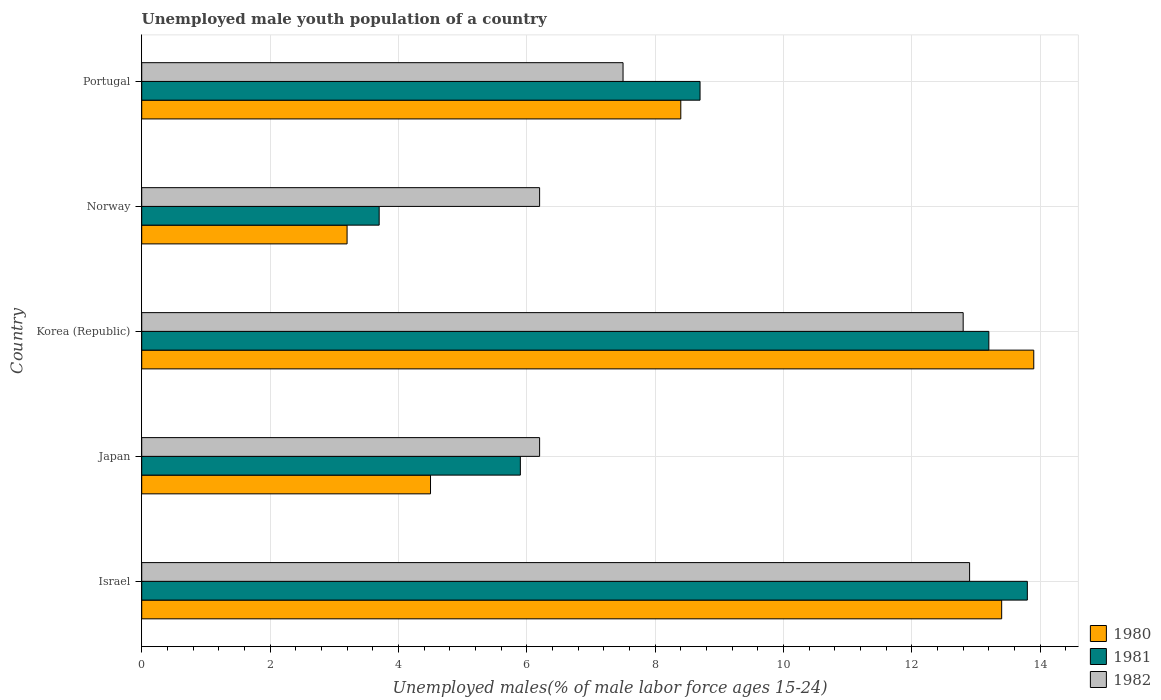How many different coloured bars are there?
Give a very brief answer. 3. Are the number of bars per tick equal to the number of legend labels?
Your answer should be compact. Yes. Are the number of bars on each tick of the Y-axis equal?
Offer a terse response. Yes. What is the label of the 2nd group of bars from the top?
Offer a very short reply. Norway. In how many cases, is the number of bars for a given country not equal to the number of legend labels?
Offer a terse response. 0. What is the percentage of unemployed male youth population in 1981 in Israel?
Your answer should be very brief. 13.8. Across all countries, what is the maximum percentage of unemployed male youth population in 1982?
Provide a succinct answer. 12.9. Across all countries, what is the minimum percentage of unemployed male youth population in 1980?
Keep it short and to the point. 3.2. In which country was the percentage of unemployed male youth population in 1980 maximum?
Offer a very short reply. Korea (Republic). In which country was the percentage of unemployed male youth population in 1981 minimum?
Your response must be concise. Norway. What is the total percentage of unemployed male youth population in 1981 in the graph?
Provide a short and direct response. 45.3. What is the difference between the percentage of unemployed male youth population in 1980 in Japan and that in Portugal?
Make the answer very short. -3.9. What is the difference between the percentage of unemployed male youth population in 1980 in Japan and the percentage of unemployed male youth population in 1981 in Korea (Republic)?
Provide a short and direct response. -8.7. What is the average percentage of unemployed male youth population in 1980 per country?
Give a very brief answer. 8.68. What is the ratio of the percentage of unemployed male youth population in 1982 in Norway to that in Portugal?
Offer a very short reply. 0.83. Is the difference between the percentage of unemployed male youth population in 1980 in Israel and Japan greater than the difference between the percentage of unemployed male youth population in 1981 in Israel and Japan?
Your answer should be compact. Yes. What is the difference between the highest and the second highest percentage of unemployed male youth population in 1980?
Provide a succinct answer. 0.5. What is the difference between the highest and the lowest percentage of unemployed male youth population in 1981?
Keep it short and to the point. 10.1. Is the sum of the percentage of unemployed male youth population in 1980 in Israel and Korea (Republic) greater than the maximum percentage of unemployed male youth population in 1981 across all countries?
Keep it short and to the point. Yes. What does the 3rd bar from the top in Israel represents?
Offer a very short reply. 1980. Is it the case that in every country, the sum of the percentage of unemployed male youth population in 1982 and percentage of unemployed male youth population in 1980 is greater than the percentage of unemployed male youth population in 1981?
Provide a short and direct response. Yes. Are all the bars in the graph horizontal?
Provide a short and direct response. Yes. What is the difference between two consecutive major ticks on the X-axis?
Ensure brevity in your answer.  2. Does the graph contain grids?
Give a very brief answer. Yes. Where does the legend appear in the graph?
Provide a succinct answer. Bottom right. How are the legend labels stacked?
Provide a short and direct response. Vertical. What is the title of the graph?
Make the answer very short. Unemployed male youth population of a country. Does "1988" appear as one of the legend labels in the graph?
Your response must be concise. No. What is the label or title of the X-axis?
Your response must be concise. Unemployed males(% of male labor force ages 15-24). What is the Unemployed males(% of male labor force ages 15-24) in 1980 in Israel?
Provide a short and direct response. 13.4. What is the Unemployed males(% of male labor force ages 15-24) in 1981 in Israel?
Your response must be concise. 13.8. What is the Unemployed males(% of male labor force ages 15-24) of 1982 in Israel?
Provide a succinct answer. 12.9. What is the Unemployed males(% of male labor force ages 15-24) of 1981 in Japan?
Offer a very short reply. 5.9. What is the Unemployed males(% of male labor force ages 15-24) of 1982 in Japan?
Make the answer very short. 6.2. What is the Unemployed males(% of male labor force ages 15-24) in 1980 in Korea (Republic)?
Your answer should be compact. 13.9. What is the Unemployed males(% of male labor force ages 15-24) in 1981 in Korea (Republic)?
Ensure brevity in your answer.  13.2. What is the Unemployed males(% of male labor force ages 15-24) in 1982 in Korea (Republic)?
Your answer should be compact. 12.8. What is the Unemployed males(% of male labor force ages 15-24) of 1980 in Norway?
Ensure brevity in your answer.  3.2. What is the Unemployed males(% of male labor force ages 15-24) in 1981 in Norway?
Offer a very short reply. 3.7. What is the Unemployed males(% of male labor force ages 15-24) of 1982 in Norway?
Your response must be concise. 6.2. What is the Unemployed males(% of male labor force ages 15-24) in 1980 in Portugal?
Keep it short and to the point. 8.4. What is the Unemployed males(% of male labor force ages 15-24) of 1981 in Portugal?
Provide a short and direct response. 8.7. Across all countries, what is the maximum Unemployed males(% of male labor force ages 15-24) of 1980?
Make the answer very short. 13.9. Across all countries, what is the maximum Unemployed males(% of male labor force ages 15-24) in 1981?
Make the answer very short. 13.8. Across all countries, what is the maximum Unemployed males(% of male labor force ages 15-24) of 1982?
Offer a very short reply. 12.9. Across all countries, what is the minimum Unemployed males(% of male labor force ages 15-24) of 1980?
Offer a very short reply. 3.2. Across all countries, what is the minimum Unemployed males(% of male labor force ages 15-24) in 1981?
Provide a succinct answer. 3.7. Across all countries, what is the minimum Unemployed males(% of male labor force ages 15-24) in 1982?
Your answer should be very brief. 6.2. What is the total Unemployed males(% of male labor force ages 15-24) of 1980 in the graph?
Make the answer very short. 43.4. What is the total Unemployed males(% of male labor force ages 15-24) of 1981 in the graph?
Your answer should be compact. 45.3. What is the total Unemployed males(% of male labor force ages 15-24) of 1982 in the graph?
Provide a succinct answer. 45.6. What is the difference between the Unemployed males(% of male labor force ages 15-24) in 1980 in Israel and that in Japan?
Keep it short and to the point. 8.9. What is the difference between the Unemployed males(% of male labor force ages 15-24) of 1981 in Israel and that in Japan?
Make the answer very short. 7.9. What is the difference between the Unemployed males(% of male labor force ages 15-24) in 1981 in Israel and that in Korea (Republic)?
Keep it short and to the point. 0.6. What is the difference between the Unemployed males(% of male labor force ages 15-24) of 1980 in Israel and that in Norway?
Offer a very short reply. 10.2. What is the difference between the Unemployed males(% of male labor force ages 15-24) of 1981 in Israel and that in Norway?
Offer a very short reply. 10.1. What is the difference between the Unemployed males(% of male labor force ages 15-24) in 1980 in Israel and that in Portugal?
Provide a short and direct response. 5. What is the difference between the Unemployed males(% of male labor force ages 15-24) in 1982 in Israel and that in Portugal?
Offer a terse response. 5.4. What is the difference between the Unemployed males(% of male labor force ages 15-24) in 1980 in Japan and that in Korea (Republic)?
Your response must be concise. -9.4. What is the difference between the Unemployed males(% of male labor force ages 15-24) of 1981 in Japan and that in Korea (Republic)?
Keep it short and to the point. -7.3. What is the difference between the Unemployed males(% of male labor force ages 15-24) in 1982 in Japan and that in Korea (Republic)?
Make the answer very short. -6.6. What is the difference between the Unemployed males(% of male labor force ages 15-24) of 1980 in Japan and that in Norway?
Provide a succinct answer. 1.3. What is the difference between the Unemployed males(% of male labor force ages 15-24) in 1980 in Japan and that in Portugal?
Provide a short and direct response. -3.9. What is the difference between the Unemployed males(% of male labor force ages 15-24) in 1981 in Japan and that in Portugal?
Your answer should be compact. -2.8. What is the difference between the Unemployed males(% of male labor force ages 15-24) of 1980 in Korea (Republic) and that in Norway?
Make the answer very short. 10.7. What is the difference between the Unemployed males(% of male labor force ages 15-24) in 1981 in Korea (Republic) and that in Norway?
Provide a succinct answer. 9.5. What is the difference between the Unemployed males(% of male labor force ages 15-24) in 1980 in Korea (Republic) and that in Portugal?
Give a very brief answer. 5.5. What is the difference between the Unemployed males(% of male labor force ages 15-24) in 1982 in Norway and that in Portugal?
Give a very brief answer. -1.3. What is the difference between the Unemployed males(% of male labor force ages 15-24) in 1981 in Israel and the Unemployed males(% of male labor force ages 15-24) in 1982 in Japan?
Offer a terse response. 7.6. What is the difference between the Unemployed males(% of male labor force ages 15-24) in 1980 in Israel and the Unemployed males(% of male labor force ages 15-24) in 1981 in Korea (Republic)?
Provide a succinct answer. 0.2. What is the difference between the Unemployed males(% of male labor force ages 15-24) of 1981 in Israel and the Unemployed males(% of male labor force ages 15-24) of 1982 in Korea (Republic)?
Offer a terse response. 1. What is the difference between the Unemployed males(% of male labor force ages 15-24) of 1980 in Israel and the Unemployed males(% of male labor force ages 15-24) of 1982 in Norway?
Give a very brief answer. 7.2. What is the difference between the Unemployed males(% of male labor force ages 15-24) in 1980 in Israel and the Unemployed males(% of male labor force ages 15-24) in 1981 in Portugal?
Offer a very short reply. 4.7. What is the difference between the Unemployed males(% of male labor force ages 15-24) in 1980 in Japan and the Unemployed males(% of male labor force ages 15-24) in 1981 in Norway?
Give a very brief answer. 0.8. What is the difference between the Unemployed males(% of male labor force ages 15-24) in 1981 in Japan and the Unemployed males(% of male labor force ages 15-24) in 1982 in Norway?
Provide a succinct answer. -0.3. What is the difference between the Unemployed males(% of male labor force ages 15-24) in 1981 in Japan and the Unemployed males(% of male labor force ages 15-24) in 1982 in Portugal?
Provide a succinct answer. -1.6. What is the difference between the Unemployed males(% of male labor force ages 15-24) of 1980 in Korea (Republic) and the Unemployed males(% of male labor force ages 15-24) of 1982 in Norway?
Offer a very short reply. 7.7. What is the difference between the Unemployed males(% of male labor force ages 15-24) of 1981 in Korea (Republic) and the Unemployed males(% of male labor force ages 15-24) of 1982 in Norway?
Make the answer very short. 7. What is the difference between the Unemployed males(% of male labor force ages 15-24) of 1980 in Korea (Republic) and the Unemployed males(% of male labor force ages 15-24) of 1982 in Portugal?
Your response must be concise. 6.4. What is the difference between the Unemployed males(% of male labor force ages 15-24) in 1980 in Norway and the Unemployed males(% of male labor force ages 15-24) in 1981 in Portugal?
Your answer should be compact. -5.5. What is the difference between the Unemployed males(% of male labor force ages 15-24) of 1980 in Norway and the Unemployed males(% of male labor force ages 15-24) of 1982 in Portugal?
Offer a terse response. -4.3. What is the difference between the Unemployed males(% of male labor force ages 15-24) of 1981 in Norway and the Unemployed males(% of male labor force ages 15-24) of 1982 in Portugal?
Give a very brief answer. -3.8. What is the average Unemployed males(% of male labor force ages 15-24) in 1980 per country?
Offer a terse response. 8.68. What is the average Unemployed males(% of male labor force ages 15-24) in 1981 per country?
Give a very brief answer. 9.06. What is the average Unemployed males(% of male labor force ages 15-24) of 1982 per country?
Provide a succinct answer. 9.12. What is the difference between the Unemployed males(% of male labor force ages 15-24) of 1980 and Unemployed males(% of male labor force ages 15-24) of 1981 in Israel?
Offer a very short reply. -0.4. What is the difference between the Unemployed males(% of male labor force ages 15-24) in 1980 and Unemployed males(% of male labor force ages 15-24) in 1982 in Israel?
Ensure brevity in your answer.  0.5. What is the difference between the Unemployed males(% of male labor force ages 15-24) of 1980 and Unemployed males(% of male labor force ages 15-24) of 1981 in Japan?
Make the answer very short. -1.4. What is the difference between the Unemployed males(% of male labor force ages 15-24) of 1981 and Unemployed males(% of male labor force ages 15-24) of 1982 in Japan?
Offer a very short reply. -0.3. What is the difference between the Unemployed males(% of male labor force ages 15-24) in 1980 and Unemployed males(% of male labor force ages 15-24) in 1982 in Norway?
Offer a very short reply. -3. What is the difference between the Unemployed males(% of male labor force ages 15-24) of 1980 and Unemployed males(% of male labor force ages 15-24) of 1981 in Portugal?
Provide a succinct answer. -0.3. What is the difference between the Unemployed males(% of male labor force ages 15-24) in 1980 and Unemployed males(% of male labor force ages 15-24) in 1982 in Portugal?
Keep it short and to the point. 0.9. What is the ratio of the Unemployed males(% of male labor force ages 15-24) of 1980 in Israel to that in Japan?
Keep it short and to the point. 2.98. What is the ratio of the Unemployed males(% of male labor force ages 15-24) of 1981 in Israel to that in Japan?
Keep it short and to the point. 2.34. What is the ratio of the Unemployed males(% of male labor force ages 15-24) in 1982 in Israel to that in Japan?
Ensure brevity in your answer.  2.08. What is the ratio of the Unemployed males(% of male labor force ages 15-24) in 1980 in Israel to that in Korea (Republic)?
Ensure brevity in your answer.  0.96. What is the ratio of the Unemployed males(% of male labor force ages 15-24) of 1981 in Israel to that in Korea (Republic)?
Provide a succinct answer. 1.05. What is the ratio of the Unemployed males(% of male labor force ages 15-24) of 1980 in Israel to that in Norway?
Provide a succinct answer. 4.19. What is the ratio of the Unemployed males(% of male labor force ages 15-24) of 1981 in Israel to that in Norway?
Ensure brevity in your answer.  3.73. What is the ratio of the Unemployed males(% of male labor force ages 15-24) of 1982 in Israel to that in Norway?
Ensure brevity in your answer.  2.08. What is the ratio of the Unemployed males(% of male labor force ages 15-24) of 1980 in Israel to that in Portugal?
Your response must be concise. 1.6. What is the ratio of the Unemployed males(% of male labor force ages 15-24) of 1981 in Israel to that in Portugal?
Provide a short and direct response. 1.59. What is the ratio of the Unemployed males(% of male labor force ages 15-24) in 1982 in Israel to that in Portugal?
Offer a terse response. 1.72. What is the ratio of the Unemployed males(% of male labor force ages 15-24) in 1980 in Japan to that in Korea (Republic)?
Provide a succinct answer. 0.32. What is the ratio of the Unemployed males(% of male labor force ages 15-24) of 1981 in Japan to that in Korea (Republic)?
Provide a succinct answer. 0.45. What is the ratio of the Unemployed males(% of male labor force ages 15-24) in 1982 in Japan to that in Korea (Republic)?
Your answer should be compact. 0.48. What is the ratio of the Unemployed males(% of male labor force ages 15-24) of 1980 in Japan to that in Norway?
Your answer should be compact. 1.41. What is the ratio of the Unemployed males(% of male labor force ages 15-24) of 1981 in Japan to that in Norway?
Provide a short and direct response. 1.59. What is the ratio of the Unemployed males(% of male labor force ages 15-24) of 1980 in Japan to that in Portugal?
Offer a very short reply. 0.54. What is the ratio of the Unemployed males(% of male labor force ages 15-24) of 1981 in Japan to that in Portugal?
Ensure brevity in your answer.  0.68. What is the ratio of the Unemployed males(% of male labor force ages 15-24) in 1982 in Japan to that in Portugal?
Ensure brevity in your answer.  0.83. What is the ratio of the Unemployed males(% of male labor force ages 15-24) of 1980 in Korea (Republic) to that in Norway?
Make the answer very short. 4.34. What is the ratio of the Unemployed males(% of male labor force ages 15-24) of 1981 in Korea (Republic) to that in Norway?
Provide a short and direct response. 3.57. What is the ratio of the Unemployed males(% of male labor force ages 15-24) in 1982 in Korea (Republic) to that in Norway?
Offer a very short reply. 2.06. What is the ratio of the Unemployed males(% of male labor force ages 15-24) of 1980 in Korea (Republic) to that in Portugal?
Make the answer very short. 1.65. What is the ratio of the Unemployed males(% of male labor force ages 15-24) of 1981 in Korea (Republic) to that in Portugal?
Offer a terse response. 1.52. What is the ratio of the Unemployed males(% of male labor force ages 15-24) in 1982 in Korea (Republic) to that in Portugal?
Ensure brevity in your answer.  1.71. What is the ratio of the Unemployed males(% of male labor force ages 15-24) of 1980 in Norway to that in Portugal?
Provide a succinct answer. 0.38. What is the ratio of the Unemployed males(% of male labor force ages 15-24) in 1981 in Norway to that in Portugal?
Ensure brevity in your answer.  0.43. What is the ratio of the Unemployed males(% of male labor force ages 15-24) of 1982 in Norway to that in Portugal?
Your response must be concise. 0.83. What is the difference between the highest and the second highest Unemployed males(% of male labor force ages 15-24) of 1980?
Provide a short and direct response. 0.5. What is the difference between the highest and the second highest Unemployed males(% of male labor force ages 15-24) of 1981?
Give a very brief answer. 0.6. What is the difference between the highest and the lowest Unemployed males(% of male labor force ages 15-24) of 1981?
Your answer should be compact. 10.1. 